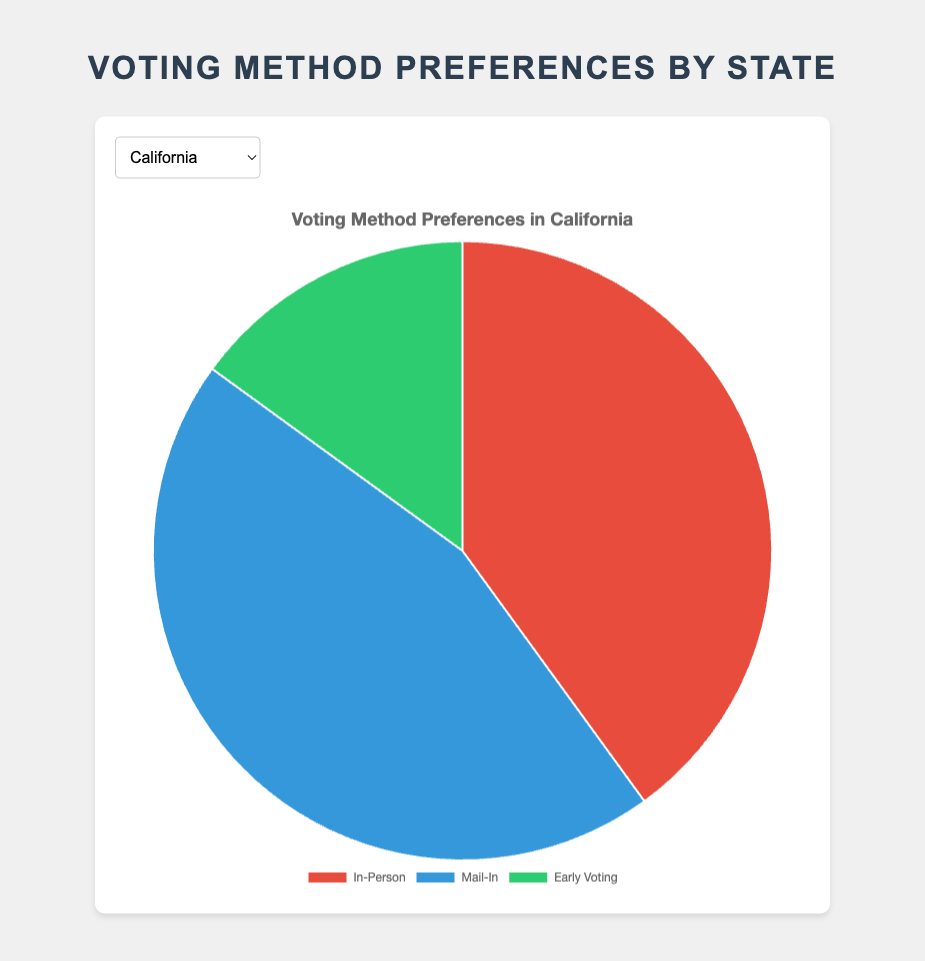What's the most preferred voting method in California? To determine the most preferred voting method in California, we check the values of In-Person (40), Mail-In (45), and Early Voting (15). Mail-In has the highest value.
Answer: Mail-In In which state is the preference for In-Person voting the highest? We compare the In-Person voting percentages across all states: California (40), Texas (50), Florida (45), New York (35), Illinois (55), Ohio (50), Georgia (60), Michigan (45), Pennsylvania (55), and North Carolina (60). Both Georgia and North Carolina have the highest In-Person preference of 60.
Answer: Georgia and North Carolina What is the total percentage of non-In-Person voting methods in Florida? To find this, we add the percentages for Mail-In and Early Voting in Florida: Mail-In (35) + Early Voting (20) = 55.
Answer: 55 Between Texas and Ohio, which has a higher preference for Mail-In voting, and by how much? Texas has 30% for Mail-In voting, while Ohio has 35%. The difference is calculated as 35 - 30 = 5.
Answer: Ohio by 5 Which state has an equal preference for Early Voting and Mail-In voting? We look for states where the percentages for Early Voting and Mail-In voting are the same. There is no such state in the given data.
Answer: None How much more is the Mail-In voting preference in New York compared to Illinois? New York has a Mail-In percentage of 50, while Illinois has 30. The difference is calculated as 50 - 30 = 20.
Answer: 20 In which state is Early Voting the least preferred method? For each state, the Early Voting percentages are: California (15), Texas (20), Florida (20), New York (15), Illinois (15), Ohio (15), Georgia (15), Michigan (15), Pennsylvania (15), and North Carolina (15). Since some states have the same percentage, they all share it as the least preferred value.
Answer: All states listed What is the combined percentage of In-Person and Early Voting preferences in Michigan? To calculate this, add the percentages for In-Person and Early Voting in Michigan: In-Person (45) + Early Voting (15) = 60.
Answer: 60 Compare the preference of Mail-In voting between California and Pennsylvania, which state shows a greater inclination for this method? California has 45% for Mail-In voting, while Pennsylvania has 30%. Comparing them, California has a higher preference.
Answer: California If you sum up the percentages of all voting methods in Georgia, do you get 100%? To confirm, add the percentages for In-Person, Mail-In, and Early Voting in Georgia: In-Person (60) + Mail-In (25) + Early Voting (15) = 100.
Answer: Yes 